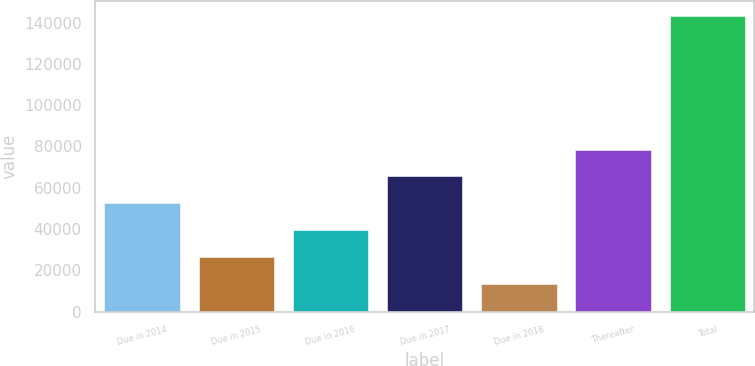<chart> <loc_0><loc_0><loc_500><loc_500><bar_chart><fcel>Due in 2014<fcel>Due in 2015<fcel>Due in 2016<fcel>Due in 2017<fcel>Due in 2018<fcel>Thereafter<fcel>Total<nl><fcel>52494<fcel>26548<fcel>39521<fcel>65467<fcel>13575<fcel>78440<fcel>143305<nl></chart> 